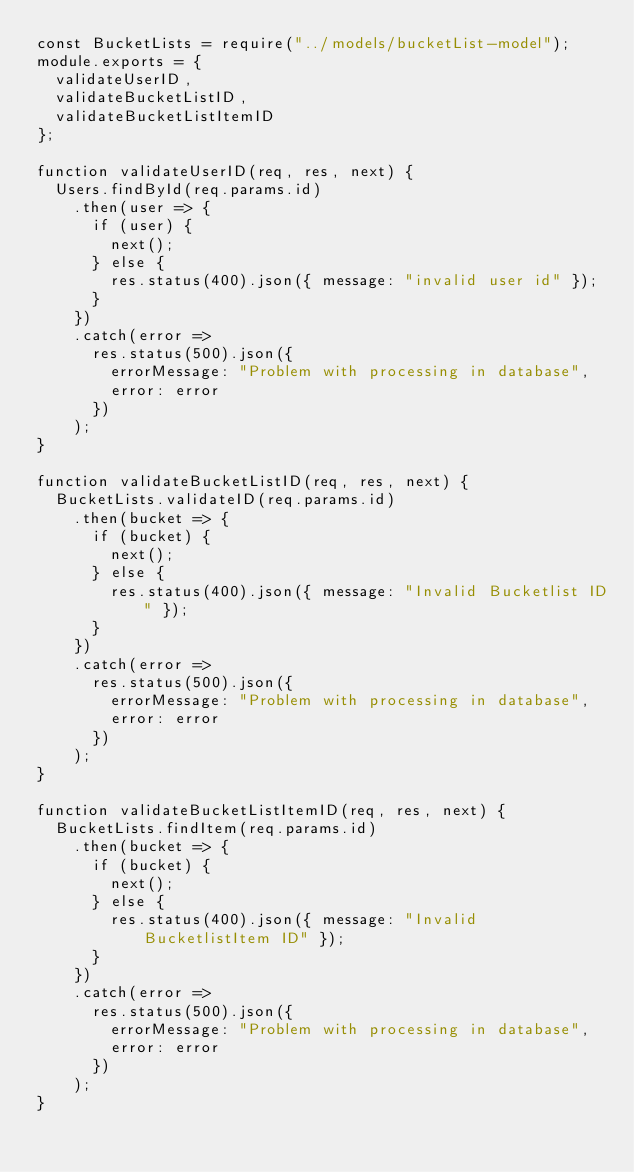Convert code to text. <code><loc_0><loc_0><loc_500><loc_500><_JavaScript_>const BucketLists = require("../models/bucketList-model");
module.exports = {
  validateUserID,
  validateBucketListID,
  validateBucketListItemID
};

function validateUserID(req, res, next) {
  Users.findById(req.params.id)
    .then(user => {
      if (user) {
        next();
      } else {
        res.status(400).json({ message: "invalid user id" });
      }
    })
    .catch(error =>
      res.status(500).json({
        errorMessage: "Problem with processing in database",
        error: error
      })
    );
}

function validateBucketListID(req, res, next) {
  BucketLists.validateID(req.params.id)
    .then(bucket => {
      if (bucket) {
        next();
      } else {
        res.status(400).json({ message: "Invalid Bucketlist ID" });
      }
    })
    .catch(error =>
      res.status(500).json({
        errorMessage: "Problem with processing in database",
        error: error
      })
    );
}

function validateBucketListItemID(req, res, next) {
  BucketLists.findItem(req.params.id)
    .then(bucket => {
      if (bucket) {
        next();
      } else {
        res.status(400).json({ message: "Invalid BucketlistItem ID" });
      }
    })
    .catch(error =>
      res.status(500).json({
        errorMessage: "Problem with processing in database",
        error: error
      })
    );
}
</code> 